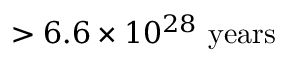<formula> <loc_0><loc_0><loc_500><loc_500>> 6 . 6 \times 1 0 ^ { 2 8 } \ y e a r s</formula> 